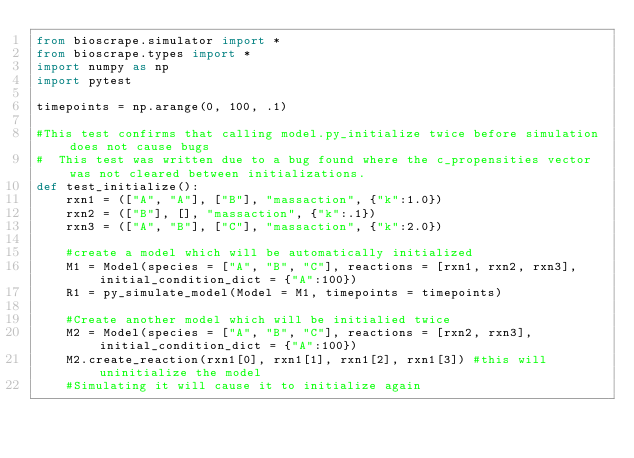<code> <loc_0><loc_0><loc_500><loc_500><_Python_>from bioscrape.simulator import *
from bioscrape.types import *
import numpy as np
import pytest

timepoints = np.arange(0, 100, .1)

#This test confirms that calling model.py_initialize twice before simulation does not cause bugs
#  This test was written due to a bug found where the c_propensities vector was not cleared between initializations.
def test_initialize():
    rxn1 = (["A", "A"], ["B"], "massaction", {"k":1.0})
    rxn2 = (["B"], [], "massaction", {"k":.1})
    rxn3 = (["A", "B"], ["C"], "massaction", {"k":2.0})

    #create a model which will be automatically initialized
    M1 = Model(species = ["A", "B", "C"], reactions = [rxn1, rxn2, rxn3], initial_condition_dict = {"A":100})
    R1 = py_simulate_model(Model = M1, timepoints = timepoints)

    #Create another model which will be initialied twice
    M2 = Model(species = ["A", "B", "C"], reactions = [rxn2, rxn3], initial_condition_dict = {"A":100})
    M2.create_reaction(rxn1[0], rxn1[1], rxn1[2], rxn1[3]) #this will uninitialize the model
    #Simulating it will cause it to initialize again</code> 